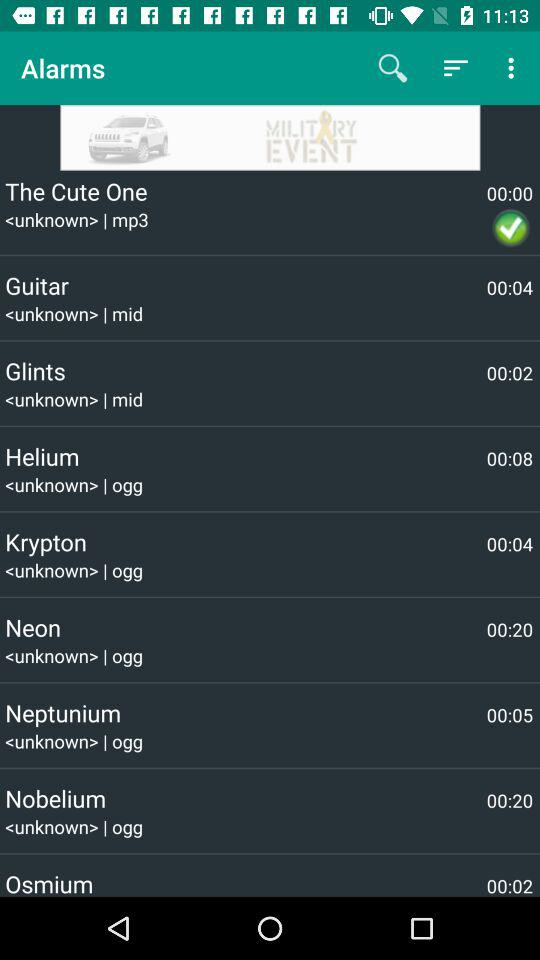How many seconds longer is the song 'Helium' than the song 'Glints'?
Answer the question using a single word or phrase. 6 